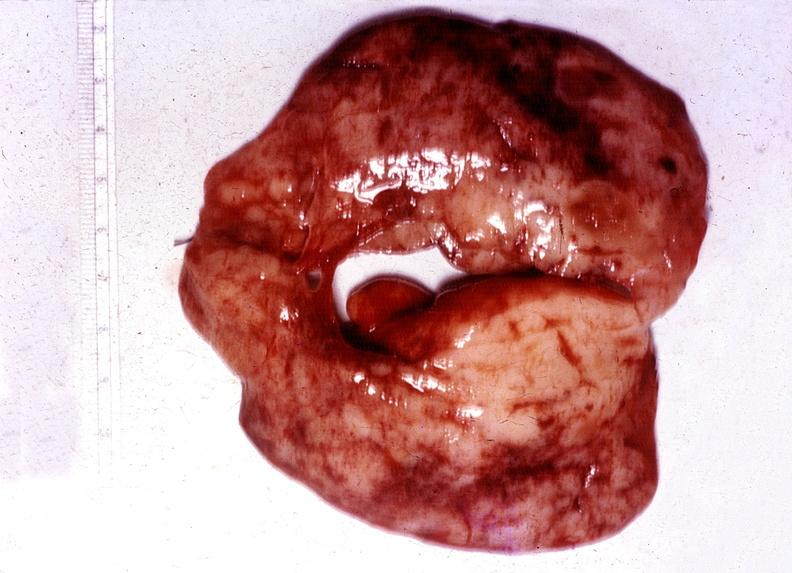where does this belong to?
Answer the question using a single word or phrase. Endocrine system 